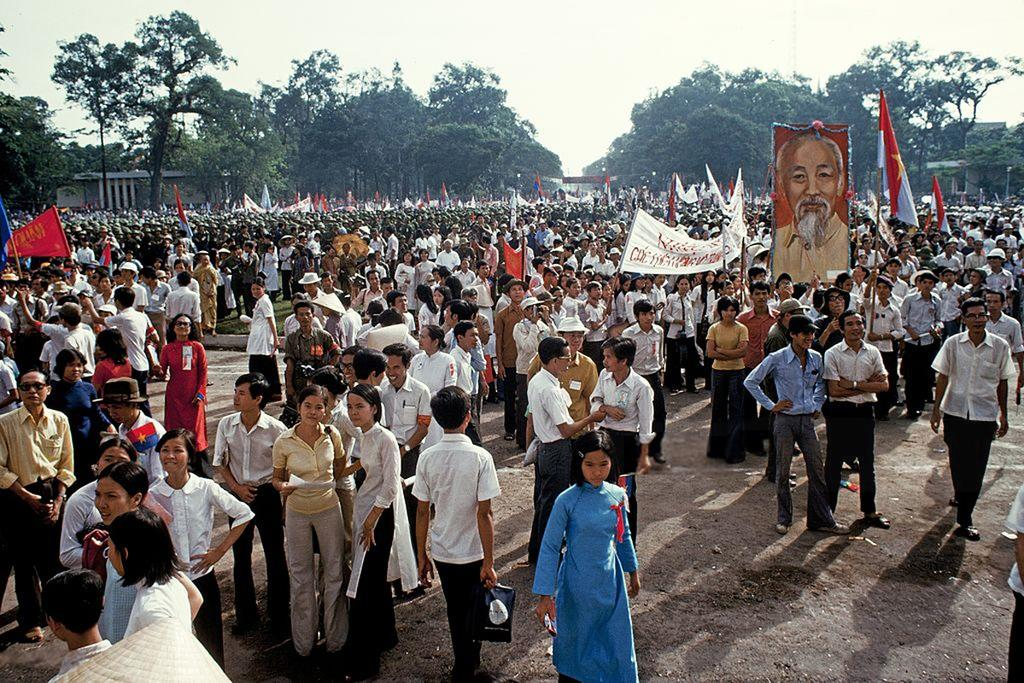What are the people in the image doing? The people in the image are holding flags and posters. What else can be seen in the image besides the people? There is a photo in the image, as well as trees and the sky visible in the background. What type of expansion can be seen in the image? There is no expansion visible in the image. What is the aftermath of the event depicted in the image? The image does not depict an event or its aftermath; it simply shows people holding flags and posters, with a photo, trees, and sky in the background. 